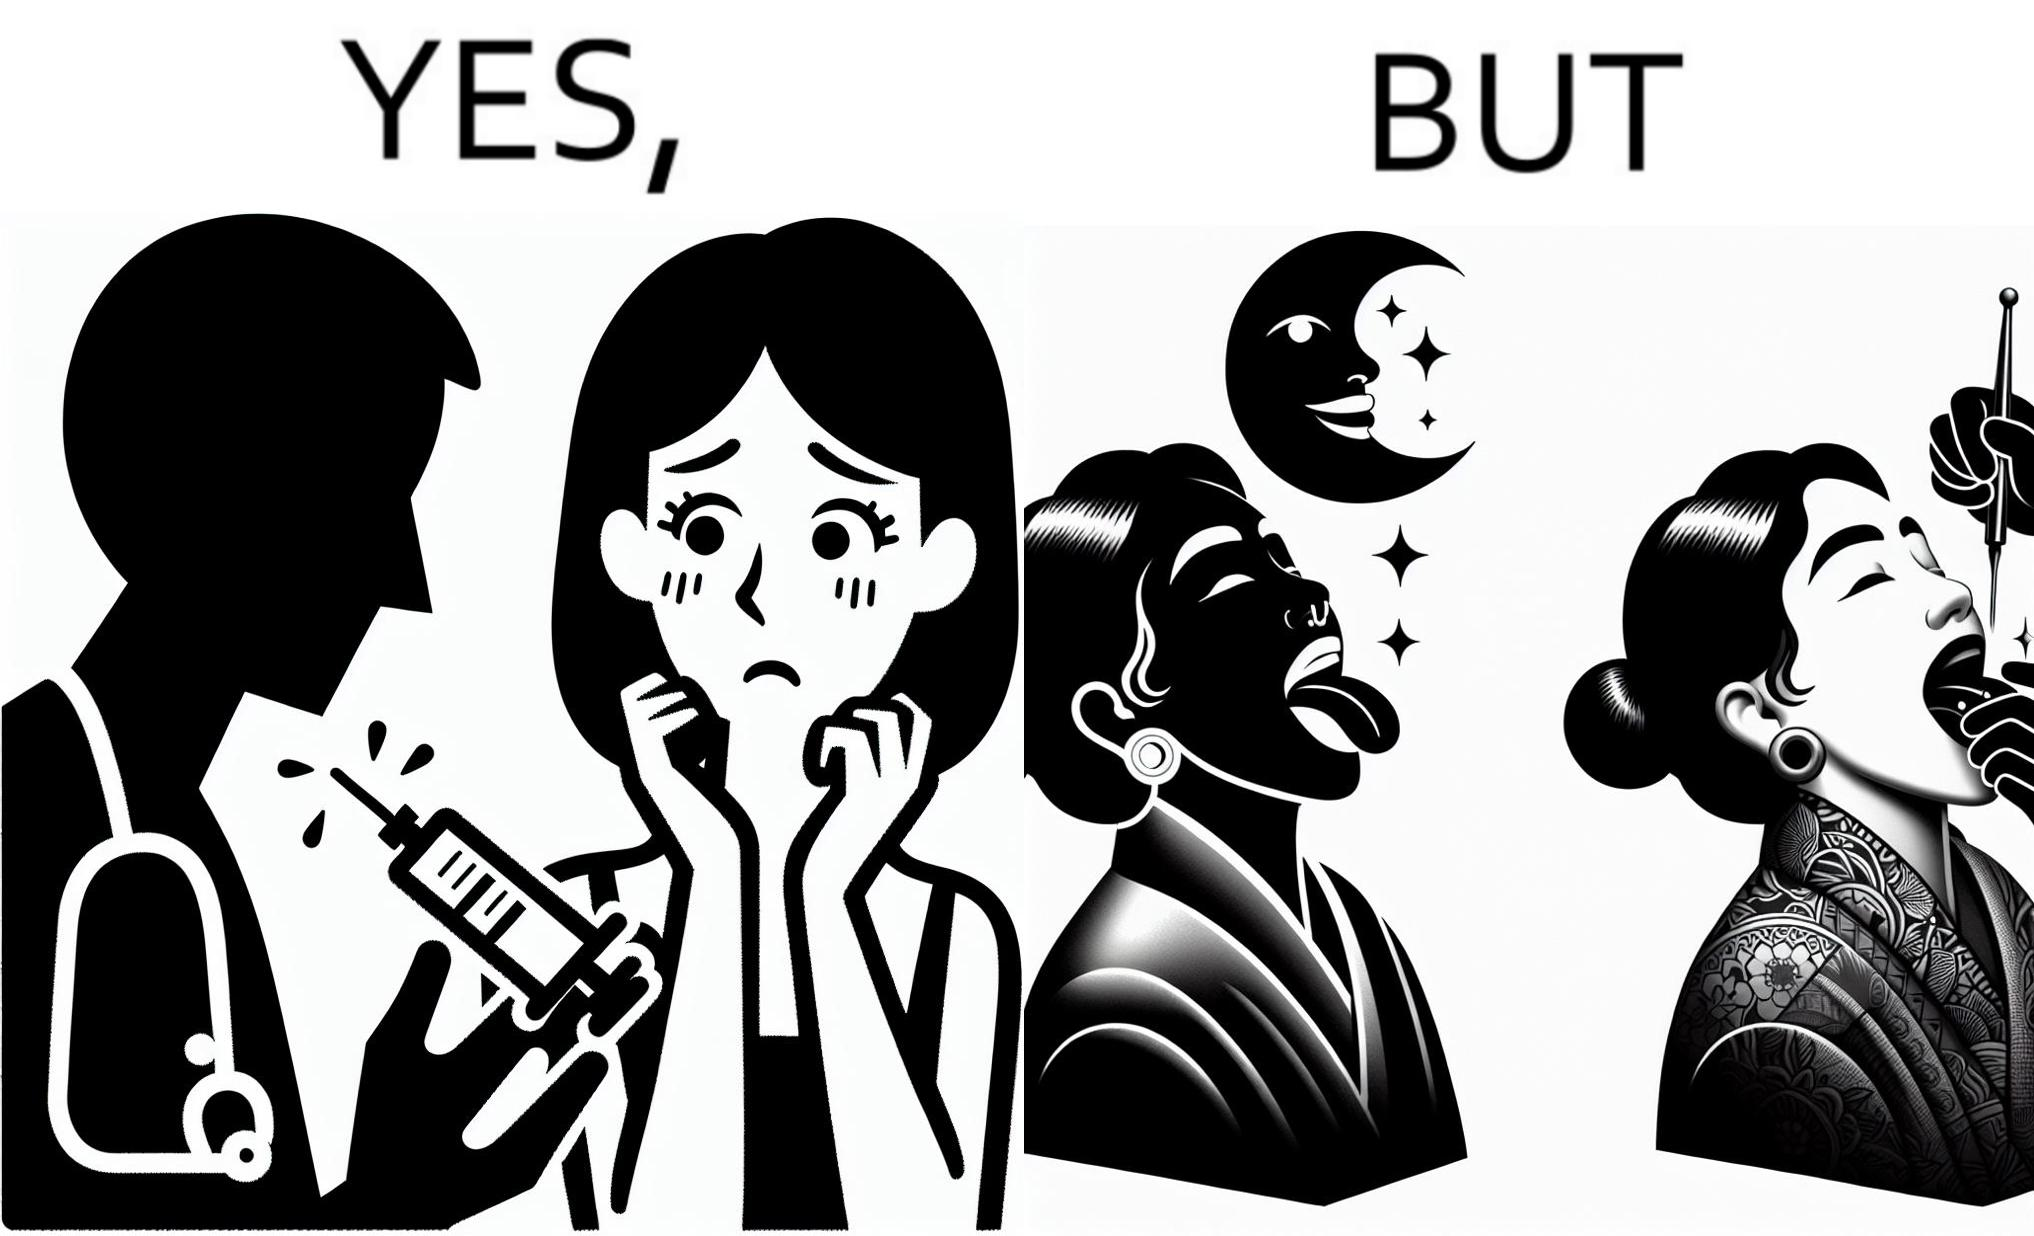Describe what you see in the left and right parts of this image. In the left part of the image: The iamge shows a woman scared of the syringe about to be used to inject her with medicine. In the right part of the image: The image shows a woman with her tongue out getting a piercing in her tongue. The image also shows shows the same woman getting tattoed on her left arm at the same time as getting  a piercing. 